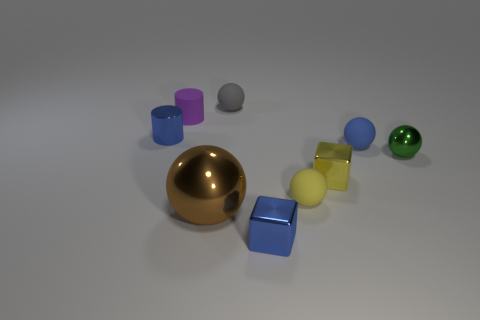There is a small ball that is the same color as the metallic cylinder; what is it made of?
Offer a very short reply. Rubber. Is there a big metal object in front of the cube that is behind the blue shiny object that is on the right side of the tiny purple object?
Provide a short and direct response. Yes. Are there more small purple rubber cylinders than tiny cubes?
Offer a very short reply. No. The metallic object to the right of the yellow cube is what color?
Offer a terse response. Green. Is the number of small rubber things that are on the left side of the small yellow rubber object greater than the number of red things?
Ensure brevity in your answer.  Yes. Does the green object have the same material as the tiny yellow cube?
Give a very brief answer. Yes. What number of other objects are the same shape as the tiny gray object?
Provide a succinct answer. 4. Is there anything else that has the same material as the big brown thing?
Keep it short and to the point. Yes. What color is the cube behind the small blue metal thing that is on the right side of the matte object to the left of the small gray rubber object?
Your answer should be compact. Yellow. Does the small object that is left of the purple rubber cylinder have the same shape as the small gray object?
Ensure brevity in your answer.  No. 